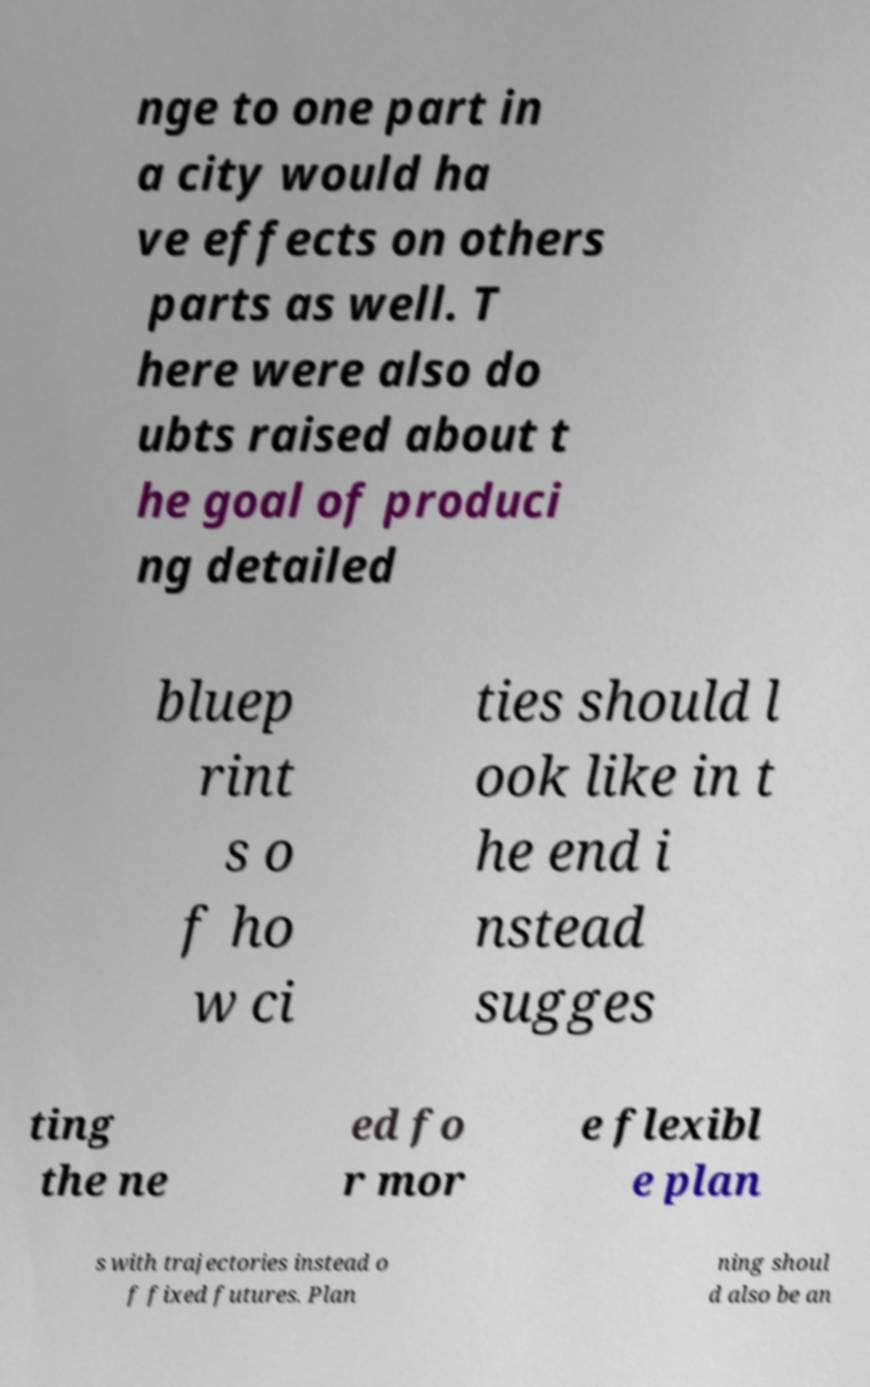For documentation purposes, I need the text within this image transcribed. Could you provide that? nge to one part in a city would ha ve effects on others parts as well. T here were also do ubts raised about t he goal of produci ng detailed bluep rint s o f ho w ci ties should l ook like in t he end i nstead sugges ting the ne ed fo r mor e flexibl e plan s with trajectories instead o f fixed futures. Plan ning shoul d also be an 